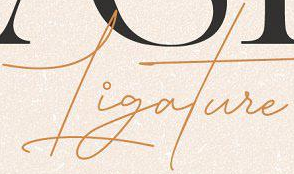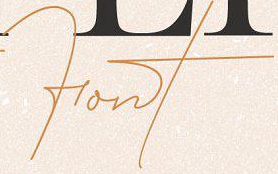Read the text content from these images in order, separated by a semicolon. Ligature; Font 